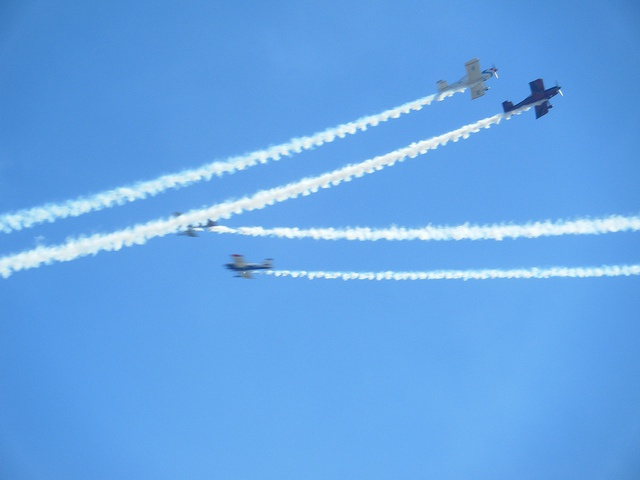Describe the objects in this image and their specific colors. I can see airplane in gray, lightblue, and lightgray tones, airplane in gray, darkblue, blue, and lightblue tones, airplane in gray and blue tones, airplane in gray and lightblue tones, and airplane in gray and lightblue tones in this image. 